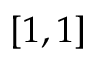Convert formula to latex. <formula><loc_0><loc_0><loc_500><loc_500>[ 1 , 1 ]</formula> 